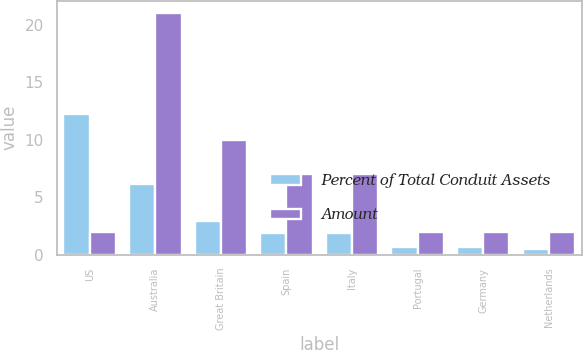Convert chart to OTSL. <chart><loc_0><loc_0><loc_500><loc_500><stacked_bar_chart><ecel><fcel>US<fcel>Australia<fcel>Great Britain<fcel>Spain<fcel>Italy<fcel>Portugal<fcel>Germany<fcel>Netherlands<nl><fcel>Percent of Total Conduit Assets<fcel>12.2<fcel>6.1<fcel>2.9<fcel>1.9<fcel>1.9<fcel>0.7<fcel>0.7<fcel>0.5<nl><fcel>Amount<fcel>2<fcel>21<fcel>10<fcel>7<fcel>7<fcel>2<fcel>2<fcel>2<nl></chart> 